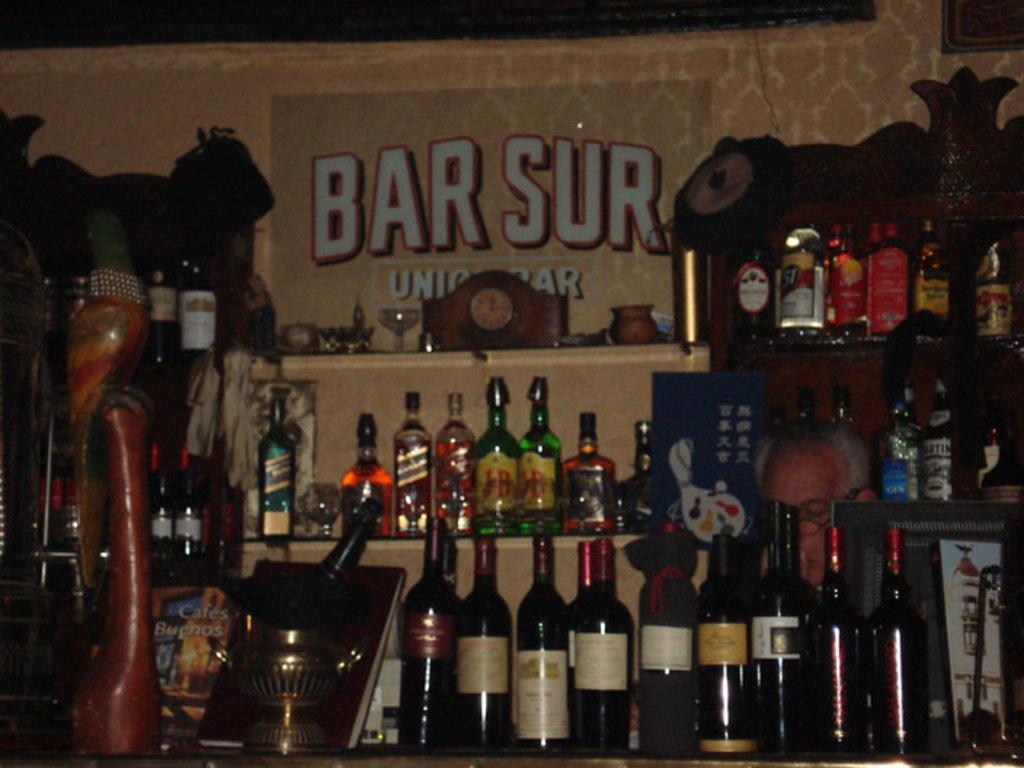In one or two sentences, can you explain what this image depicts? Here is a wine bottles and beer bottles placed in the rack. This looks like a poster attached to the wall. I can see a man here. At the left side I can see some wooden object. 